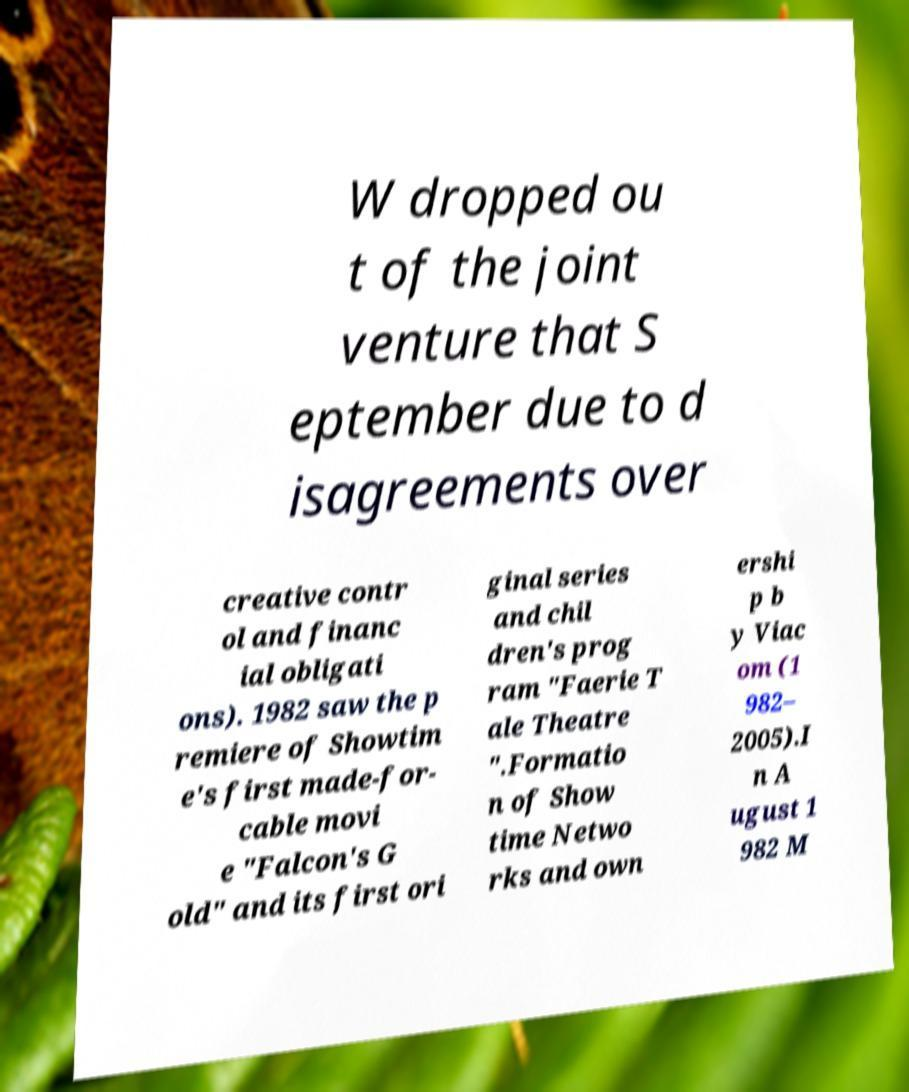For documentation purposes, I need the text within this image transcribed. Could you provide that? W dropped ou t of the joint venture that S eptember due to d isagreements over creative contr ol and financ ial obligati ons). 1982 saw the p remiere of Showtim e's first made-for- cable movi e "Falcon's G old" and its first ori ginal series and chil dren's prog ram "Faerie T ale Theatre ".Formatio n of Show time Netwo rks and own ershi p b y Viac om (1 982– 2005).I n A ugust 1 982 M 